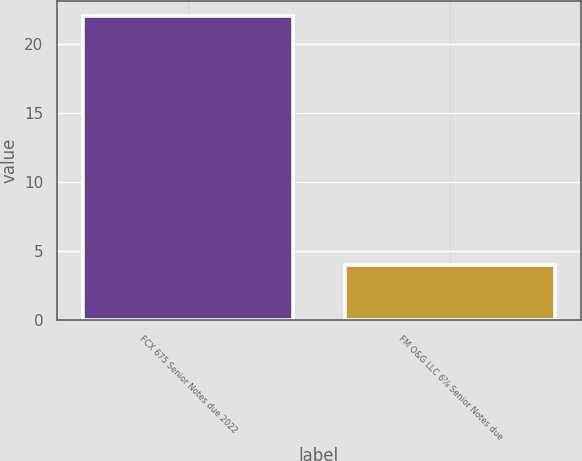Convert chart. <chart><loc_0><loc_0><loc_500><loc_500><bar_chart><fcel>FCX 675 Senior Notes due 2022<fcel>FM O&G LLC 6⅞ Senior Notes due<nl><fcel>22<fcel>4<nl></chart> 